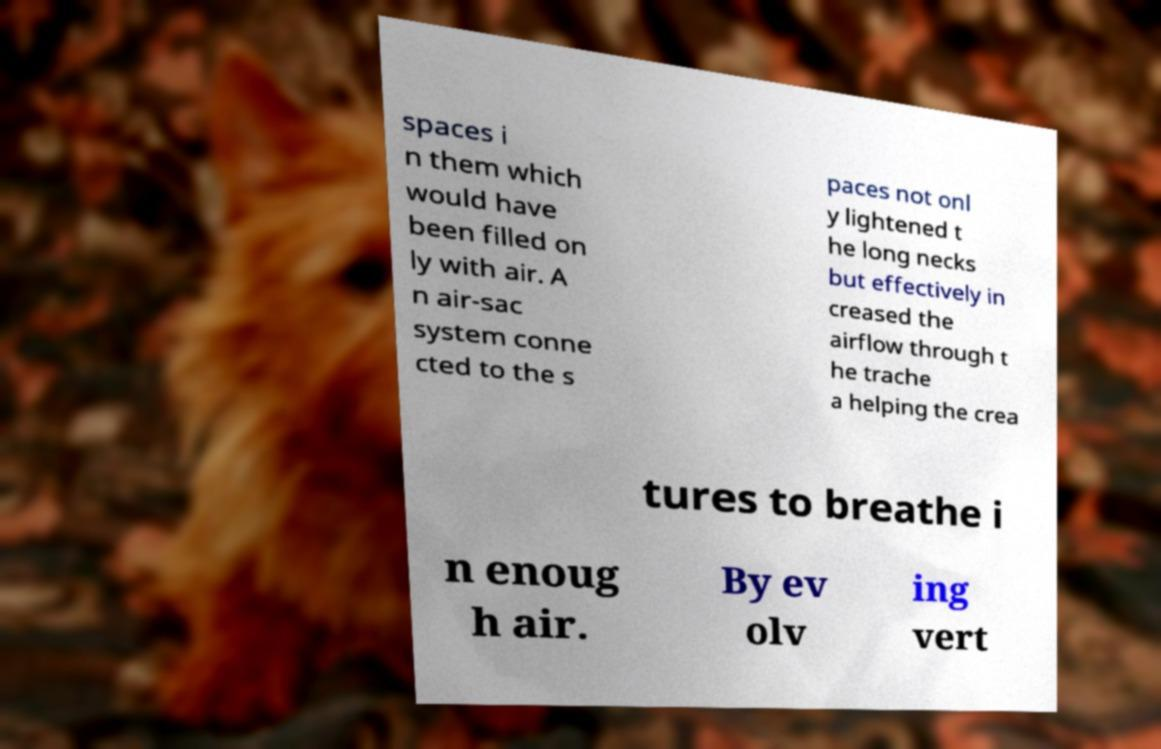Please read and relay the text visible in this image. What does it say? spaces i n them which would have been filled on ly with air. A n air-sac system conne cted to the s paces not onl y lightened t he long necks but effectively in creased the airflow through t he trache a helping the crea tures to breathe i n enoug h air. By ev olv ing vert 